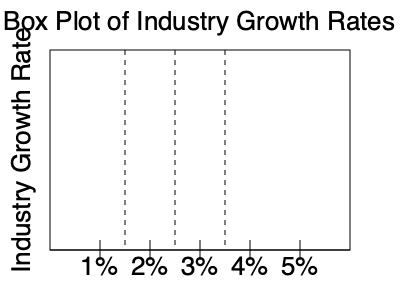Given the box plot of industry growth rates, calculate the mean and median growth rates. Which measure of central tendency would you recommend using to represent the typical growth rate in this industry, and why? To solve this problem, let's follow these steps:

1. Identify the key values from the box plot:
   - Minimum: 1%
   - First quartile (Q1): 1.5%
   - Median (Q2): 2.5%
   - Third quartile (Q3): 3.5%
   - Maximum: 5%

2. Calculate the median:
   The median is already given by the center line of the box plot: 2.5%

3. Calculate the mean:
   To estimate the mean, we can use the formula:
   $$ \text{Mean} \approx \frac{\text{Min} + 2Q1 + 2Q2 + 2Q3 + \text{Max}}{7} $$
   
   Plugging in the values:
   $$ \text{Mean} \approx \frac{1 + 2(1.5) + 2(2.5) + 2(3.5) + 5}{7} $$
   $$ \text{Mean} \approx \frac{1 + 3 + 5 + 7 + 5}{7} = \frac{21}{7} = 3\% $$

4. Comparing mean and median:
   - Median: 2.5%
   - Mean: 3%

   The mean is higher than the median, indicating that the distribution is slightly skewed to the right.

5. Recommendation:
   In this case, the median (2.5%) would be a better measure of central tendency to represent the typical growth rate in this industry. Here's why:
   - The median is less affected by extreme values or outliers.
   - The box plot shows a slight right skew, which can pull the mean higher than the typical value.
   - The median represents the middle value, with 50% of the growth rates above and 50% below, giving a more balanced representation of the typical growth rate.
Answer: Mean: 3%, Median: 2.5%. Recommend using median due to right skew. 